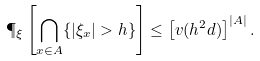Convert formula to latex. <formula><loc_0><loc_0><loc_500><loc_500>\P _ { \xi } \left [ \bigcap _ { x \in A } \{ | \xi _ { x } | > h \} \right ] \leq \left [ v ( h ^ { 2 } d ) \right ] ^ { | A | } .</formula> 